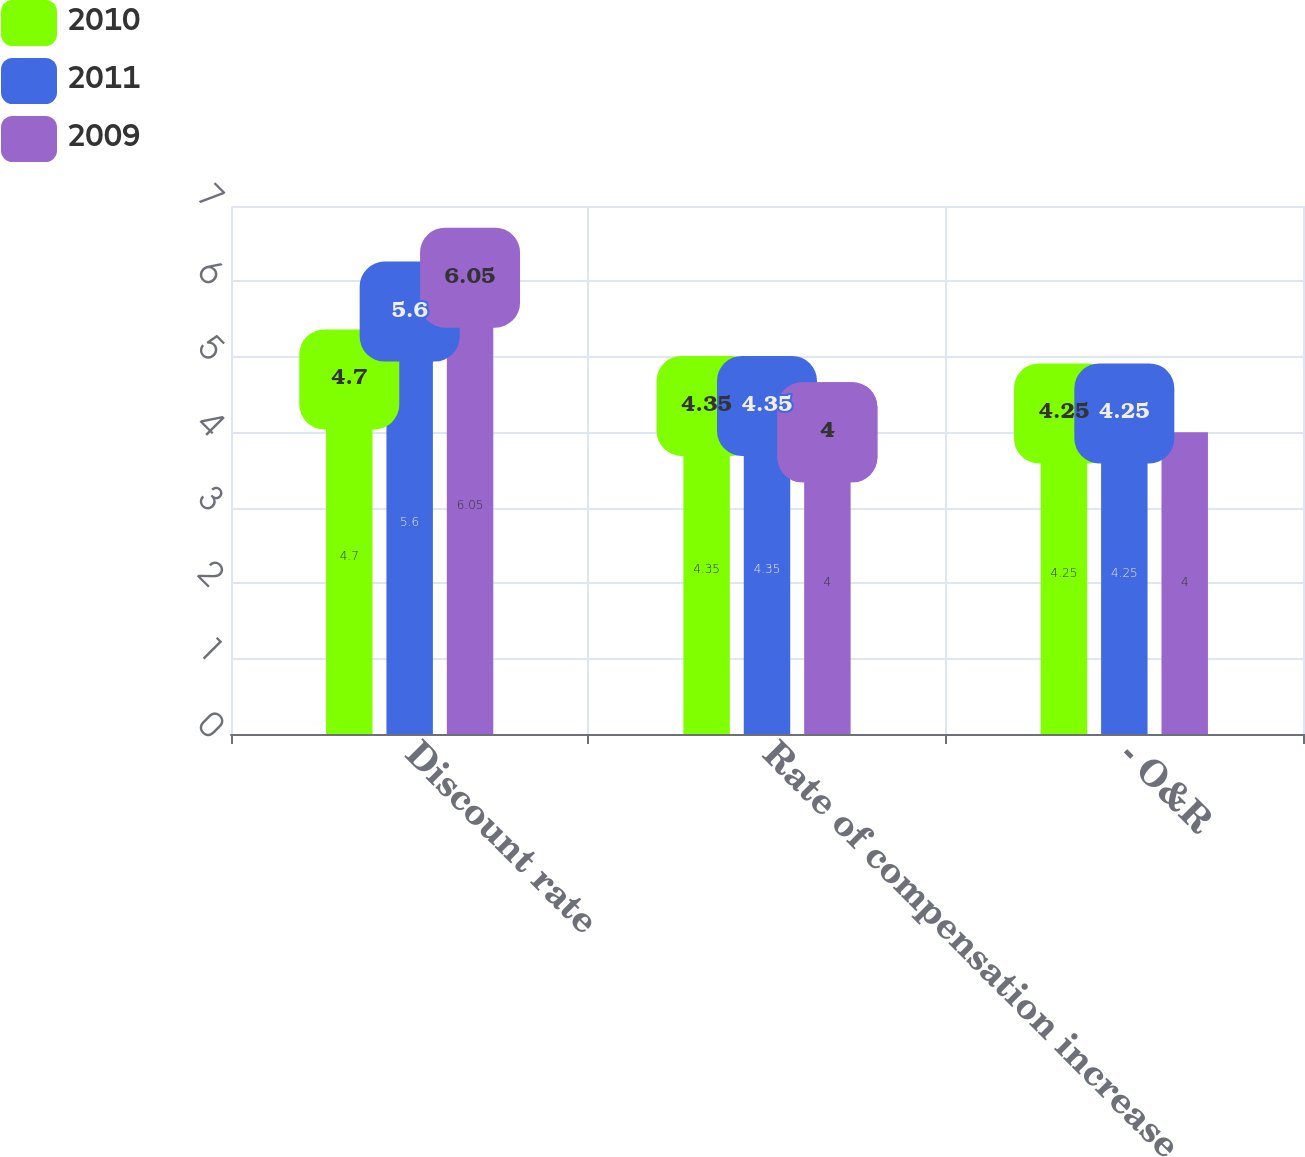Convert chart to OTSL. <chart><loc_0><loc_0><loc_500><loc_500><stacked_bar_chart><ecel><fcel>Discount rate<fcel>Rate of compensation increase<fcel>- O&R<nl><fcel>2010<fcel>4.7<fcel>4.35<fcel>4.25<nl><fcel>2011<fcel>5.6<fcel>4.35<fcel>4.25<nl><fcel>2009<fcel>6.05<fcel>4<fcel>4<nl></chart> 